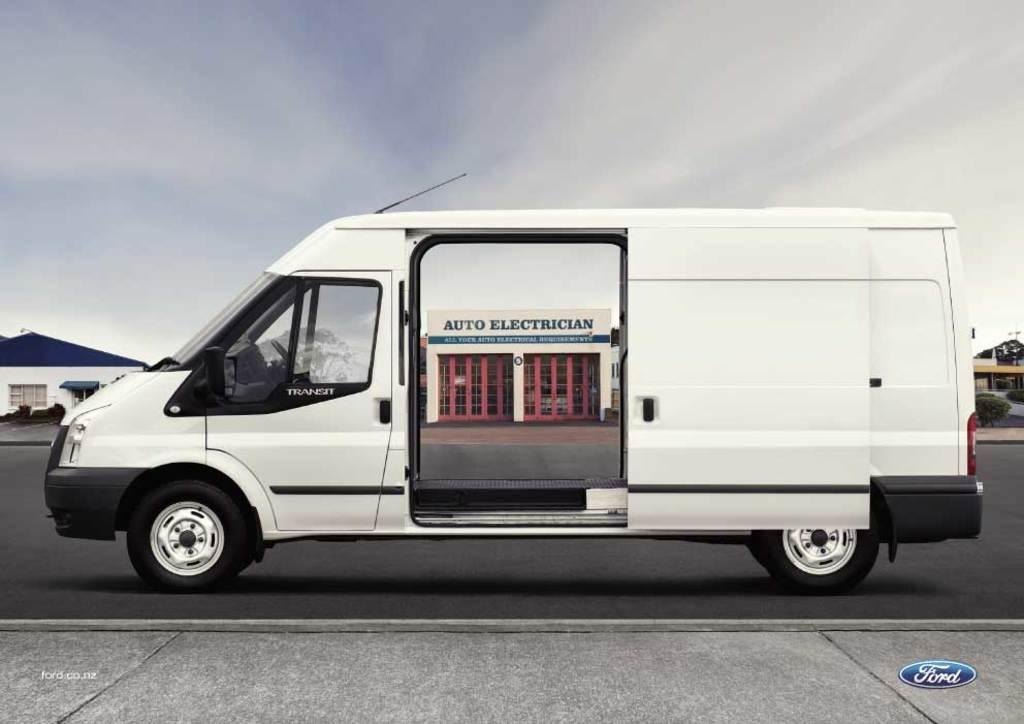<image>
Provide a brief description of the given image. A white van door is open to an Auto Electrician building. 